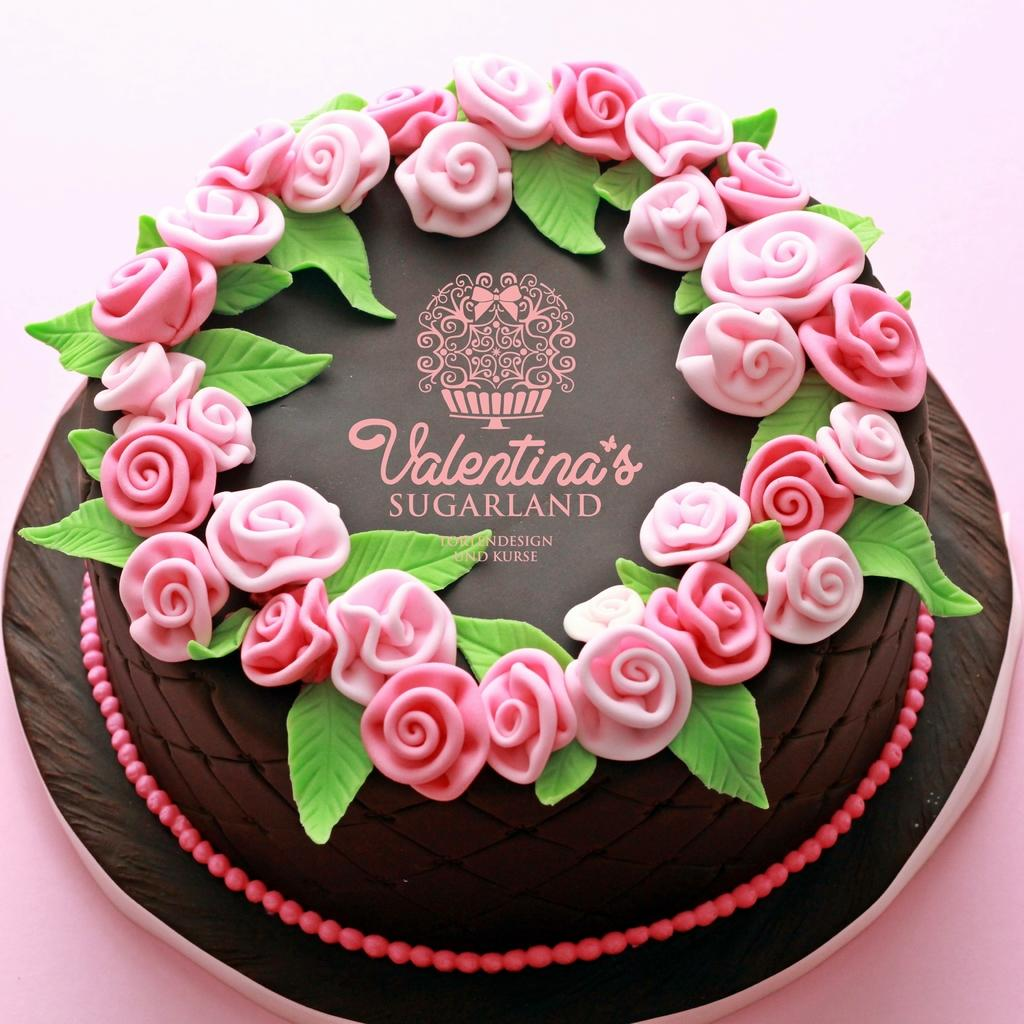What is the main subject of the image? The main subject of the image is a cake. How is the cake presented in the image? The cake is placed on a plate in the image. What decorative elements are present on the cake? Roses are designed on the cake. How many men are standing next to the cake in the image? There are no men present in the image; it only features a cake with roses on it. What type of fruit is placed on top of the cake in the image? There is no fruit present on the cake in the image; it is decorated with roses. 